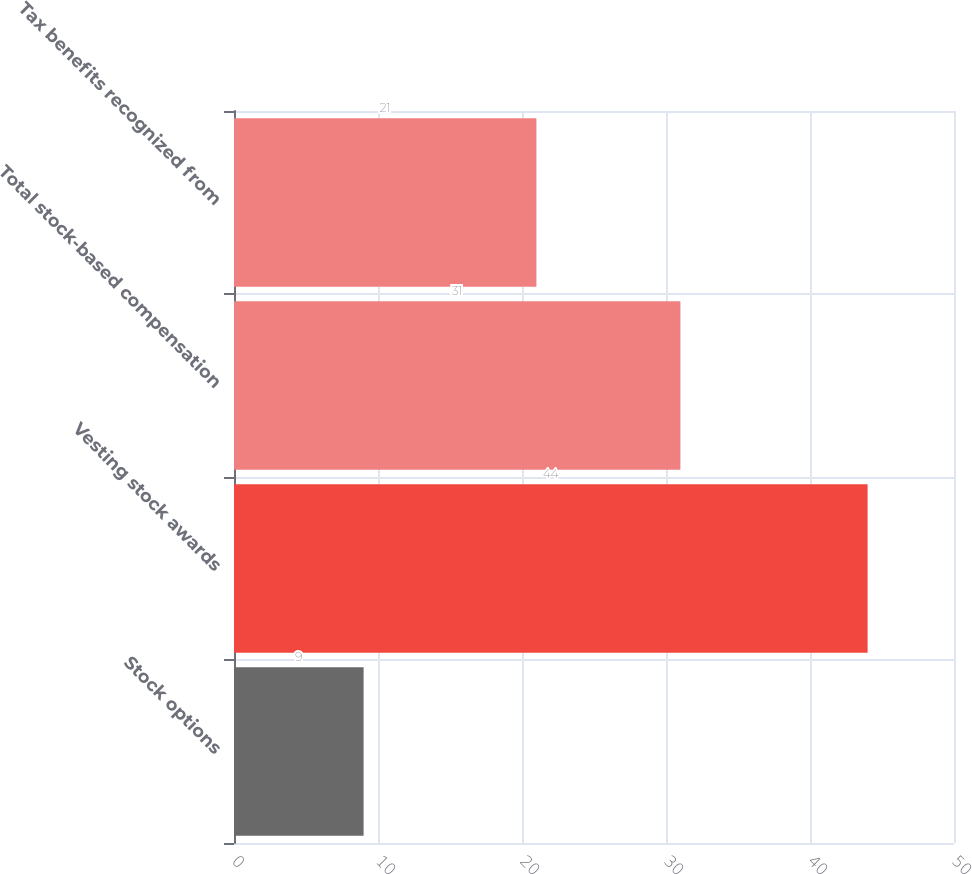<chart> <loc_0><loc_0><loc_500><loc_500><bar_chart><fcel>Stock options<fcel>Vesting stock awards<fcel>Total stock-based compensation<fcel>Tax benefits recognized from<nl><fcel>9<fcel>44<fcel>31<fcel>21<nl></chart> 